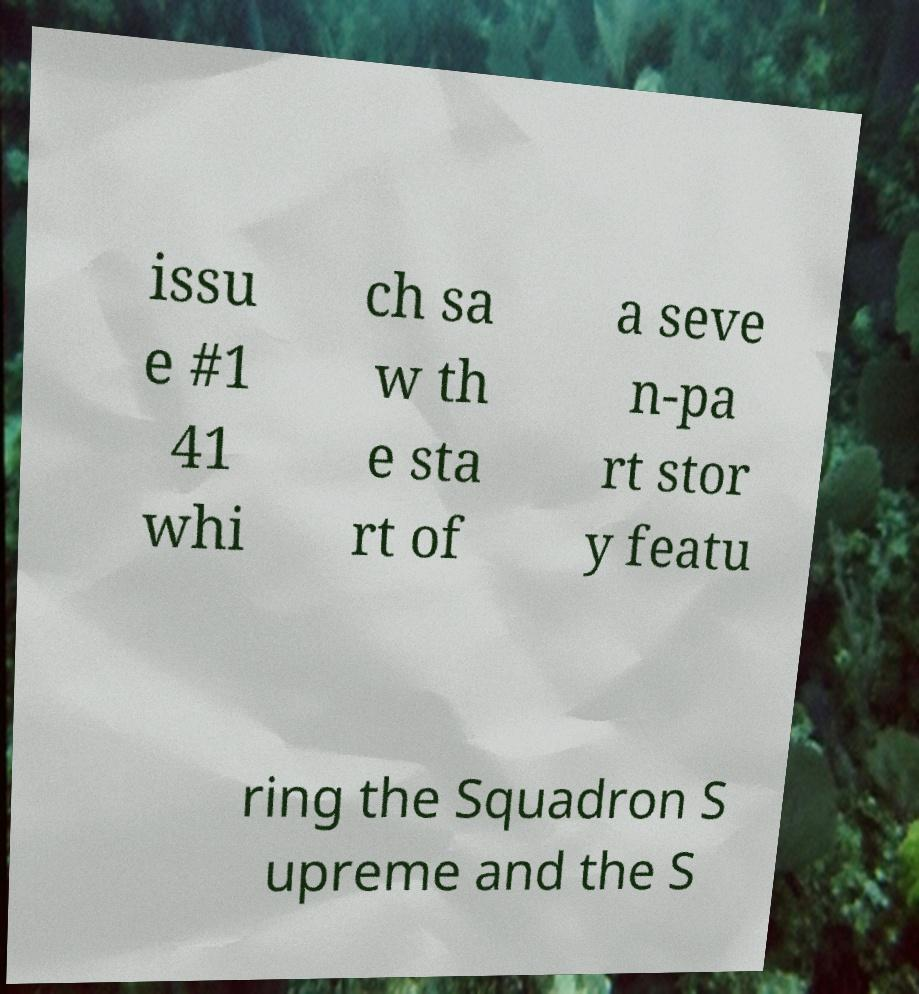Could you extract and type out the text from this image? issu e #1 41 whi ch sa w th e sta rt of a seve n-pa rt stor y featu ring the Squadron S upreme and the S 